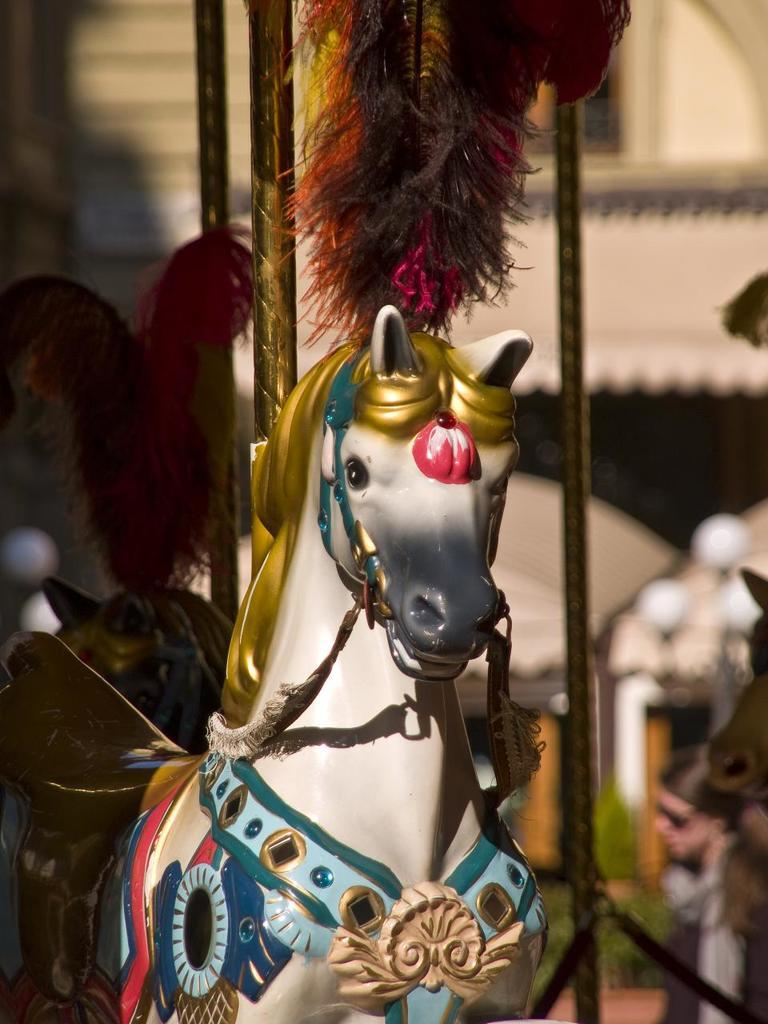What is the main subject in the foreground of the image? There is an artificial horse in the foreground of the image. How is the background of the image depicted? The background of the horse is blurred. What type of boats can be seen in the image? There are no boats present in the image; it features an artificial horse in the foreground. What is the title of the image? The provided facts do not mention a title for the image. 